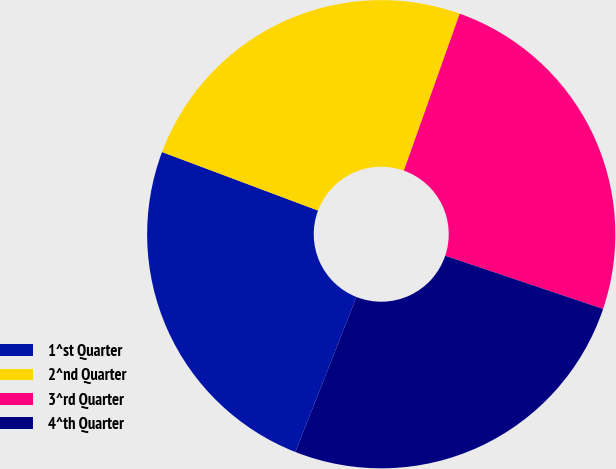Convert chart to OTSL. <chart><loc_0><loc_0><loc_500><loc_500><pie_chart><fcel>1^st Quarter<fcel>2^nd Quarter<fcel>3^rd Quarter<fcel>4^th Quarter<nl><fcel>24.73%<fcel>24.73%<fcel>24.73%<fcel>25.81%<nl></chart> 